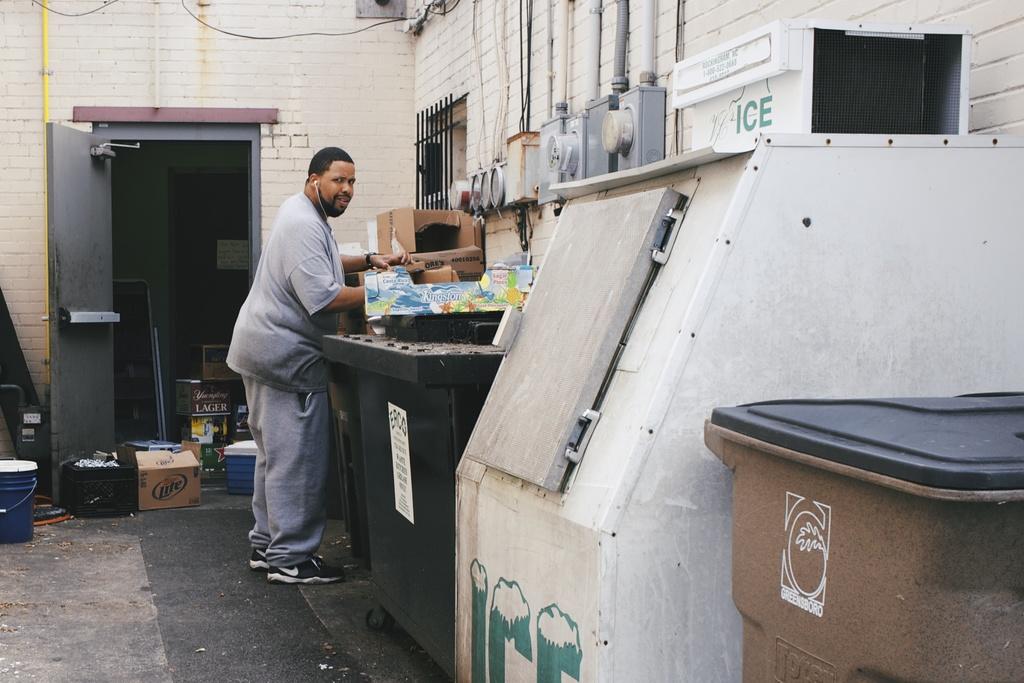What is the white machine making?
Your answer should be very brief. Ice. 